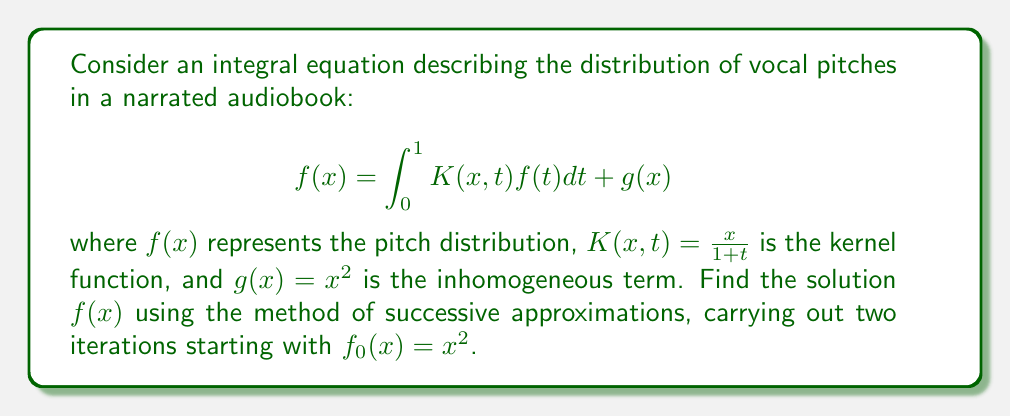Give your solution to this math problem. To solve this integral equation using the method of successive approximations:

1) Start with $f_0(x) = x^2$

2) For the first iteration:
   $$f_1(x) = \int_0^1 K(x,t)f_0(t)dt + g(x)$$
   $$f_1(x) = \int_0^1 \frac{x}{1+t} \cdot t^2 dt + x^2$$
   $$f_1(x) = x \int_0^1 \frac{t^2}{1+t} dt + x^2$$
   
   Let $u = \frac{t^2}{1+t}$, then $du = \frac{2t(1+t) - t^2}{(1+t)^2} dt = \frac{2t+2t^2-t^2}{(1+t)^2} dt = \frac{2t+t^2}{(1+t)^2} dt$
   
   $$f_1(x) = x \left[t - 2\ln(1+t) + \frac{2}{1+t}\right]_0^1 + x^2$$
   $$f_1(x) = x \left[1 - 2\ln(2) + 1 - (0 - 2\ln(1) + 2)\right] + x^2$$
   $$f_1(x) = x(2 - 2\ln(2)) + x^2$$

3) For the second iteration:
   $$f_2(x) = \int_0^1 K(x,t)f_1(t)dt + g(x)$$
   $$f_2(x) = \int_0^1 \frac{x}{1+t} \cdot [t(2 - 2\ln(2)) + t^2] dt + x^2$$
   $$f_2(x) = x \int_0^1 \frac{t(2 - 2\ln(2)) + t^2}{1+t} dt + x^2$$
   $$f_2(x) = x \int_0^1 [(2 - 2\ln(2))(1 - \frac{1}{1+t}) + (t - \frac{1}{1+t})] dt + x^2$$
   $$f_2(x) = x [(2 - 2\ln(2))(t - \ln(1+t)) + (\frac{t^2}{2} + \ln(1+t))]_0^1 + x^2$$
   $$f_2(x) = x [(2 - 2\ln(2))(1 - \ln(2)) + (\frac{1}{2} + \ln(2))] + x^2$$
   $$f_2(x) = x [2 - 2\ln(2) - 2\ln(2) + 2(\ln(2))^2 + \frac{1}{2} + \ln(2)] + x^2$$
   $$f_2(x) = x [\frac{5}{2} - 3\ln(2) + 2(\ln(2))^2] + x^2$$
Answer: $f(x) \approx x [\frac{5}{2} - 3\ln(2) + 2(\ln(2))^2] + x^2$ 